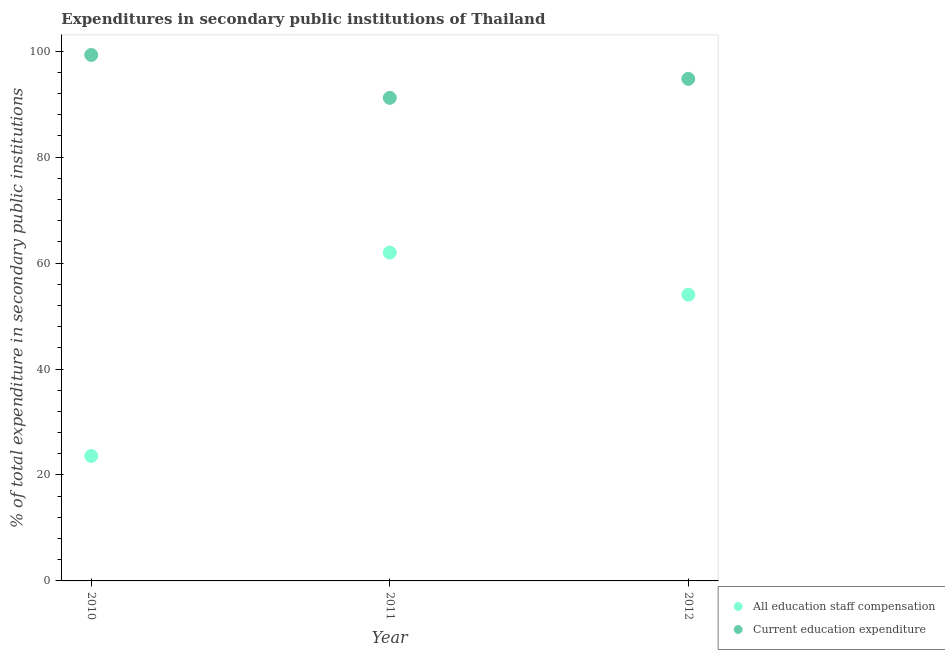What is the expenditure in staff compensation in 2010?
Offer a very short reply. 23.58. Across all years, what is the maximum expenditure in staff compensation?
Provide a short and direct response. 61.98. Across all years, what is the minimum expenditure in education?
Keep it short and to the point. 91.18. What is the total expenditure in education in the graph?
Keep it short and to the point. 285.24. What is the difference between the expenditure in staff compensation in 2010 and that in 2011?
Ensure brevity in your answer.  -38.4. What is the difference between the expenditure in staff compensation in 2011 and the expenditure in education in 2010?
Make the answer very short. -37.31. What is the average expenditure in staff compensation per year?
Make the answer very short. 46.53. In the year 2010, what is the difference between the expenditure in staff compensation and expenditure in education?
Offer a terse response. -75.7. What is the ratio of the expenditure in education in 2010 to that in 2011?
Your answer should be compact. 1.09. Is the expenditure in staff compensation in 2010 less than that in 2012?
Your answer should be compact. Yes. Is the difference between the expenditure in education in 2010 and 2012 greater than the difference between the expenditure in staff compensation in 2010 and 2012?
Offer a very short reply. Yes. What is the difference between the highest and the second highest expenditure in education?
Offer a very short reply. 4.52. What is the difference between the highest and the lowest expenditure in education?
Offer a very short reply. 8.1. Does the expenditure in staff compensation monotonically increase over the years?
Provide a succinct answer. No. Is the expenditure in education strictly less than the expenditure in staff compensation over the years?
Your answer should be compact. No. What is the difference between two consecutive major ticks on the Y-axis?
Your answer should be very brief. 20. Does the graph contain grids?
Offer a terse response. No. Where does the legend appear in the graph?
Give a very brief answer. Bottom right. What is the title of the graph?
Give a very brief answer. Expenditures in secondary public institutions of Thailand. What is the label or title of the Y-axis?
Keep it short and to the point. % of total expenditure in secondary public institutions. What is the % of total expenditure in secondary public institutions in All education staff compensation in 2010?
Provide a short and direct response. 23.58. What is the % of total expenditure in secondary public institutions of Current education expenditure in 2010?
Provide a succinct answer. 99.29. What is the % of total expenditure in secondary public institutions of All education staff compensation in 2011?
Make the answer very short. 61.98. What is the % of total expenditure in secondary public institutions in Current education expenditure in 2011?
Your answer should be very brief. 91.18. What is the % of total expenditure in secondary public institutions of All education staff compensation in 2012?
Your answer should be very brief. 54.03. What is the % of total expenditure in secondary public institutions in Current education expenditure in 2012?
Provide a succinct answer. 94.77. Across all years, what is the maximum % of total expenditure in secondary public institutions of All education staff compensation?
Make the answer very short. 61.98. Across all years, what is the maximum % of total expenditure in secondary public institutions in Current education expenditure?
Your answer should be compact. 99.29. Across all years, what is the minimum % of total expenditure in secondary public institutions of All education staff compensation?
Make the answer very short. 23.58. Across all years, what is the minimum % of total expenditure in secondary public institutions of Current education expenditure?
Make the answer very short. 91.18. What is the total % of total expenditure in secondary public institutions in All education staff compensation in the graph?
Offer a terse response. 139.59. What is the total % of total expenditure in secondary public institutions in Current education expenditure in the graph?
Make the answer very short. 285.24. What is the difference between the % of total expenditure in secondary public institutions in All education staff compensation in 2010 and that in 2011?
Your answer should be compact. -38.4. What is the difference between the % of total expenditure in secondary public institutions in Current education expenditure in 2010 and that in 2011?
Your answer should be compact. 8.1. What is the difference between the % of total expenditure in secondary public institutions in All education staff compensation in 2010 and that in 2012?
Offer a very short reply. -30.45. What is the difference between the % of total expenditure in secondary public institutions in Current education expenditure in 2010 and that in 2012?
Provide a succinct answer. 4.52. What is the difference between the % of total expenditure in secondary public institutions in All education staff compensation in 2011 and that in 2012?
Provide a short and direct response. 7.95. What is the difference between the % of total expenditure in secondary public institutions of Current education expenditure in 2011 and that in 2012?
Provide a short and direct response. -3.59. What is the difference between the % of total expenditure in secondary public institutions of All education staff compensation in 2010 and the % of total expenditure in secondary public institutions of Current education expenditure in 2011?
Your answer should be very brief. -67.6. What is the difference between the % of total expenditure in secondary public institutions in All education staff compensation in 2010 and the % of total expenditure in secondary public institutions in Current education expenditure in 2012?
Keep it short and to the point. -71.19. What is the difference between the % of total expenditure in secondary public institutions in All education staff compensation in 2011 and the % of total expenditure in secondary public institutions in Current education expenditure in 2012?
Ensure brevity in your answer.  -32.79. What is the average % of total expenditure in secondary public institutions in All education staff compensation per year?
Ensure brevity in your answer.  46.53. What is the average % of total expenditure in secondary public institutions in Current education expenditure per year?
Your answer should be compact. 95.08. In the year 2010, what is the difference between the % of total expenditure in secondary public institutions of All education staff compensation and % of total expenditure in secondary public institutions of Current education expenditure?
Your response must be concise. -75.7. In the year 2011, what is the difference between the % of total expenditure in secondary public institutions in All education staff compensation and % of total expenditure in secondary public institutions in Current education expenditure?
Offer a terse response. -29.2. In the year 2012, what is the difference between the % of total expenditure in secondary public institutions in All education staff compensation and % of total expenditure in secondary public institutions in Current education expenditure?
Provide a short and direct response. -40.74. What is the ratio of the % of total expenditure in secondary public institutions in All education staff compensation in 2010 to that in 2011?
Provide a succinct answer. 0.38. What is the ratio of the % of total expenditure in secondary public institutions of Current education expenditure in 2010 to that in 2011?
Make the answer very short. 1.09. What is the ratio of the % of total expenditure in secondary public institutions in All education staff compensation in 2010 to that in 2012?
Your answer should be very brief. 0.44. What is the ratio of the % of total expenditure in secondary public institutions of Current education expenditure in 2010 to that in 2012?
Give a very brief answer. 1.05. What is the ratio of the % of total expenditure in secondary public institutions of All education staff compensation in 2011 to that in 2012?
Your answer should be compact. 1.15. What is the ratio of the % of total expenditure in secondary public institutions in Current education expenditure in 2011 to that in 2012?
Provide a succinct answer. 0.96. What is the difference between the highest and the second highest % of total expenditure in secondary public institutions of All education staff compensation?
Keep it short and to the point. 7.95. What is the difference between the highest and the second highest % of total expenditure in secondary public institutions in Current education expenditure?
Ensure brevity in your answer.  4.52. What is the difference between the highest and the lowest % of total expenditure in secondary public institutions of All education staff compensation?
Offer a terse response. 38.4. What is the difference between the highest and the lowest % of total expenditure in secondary public institutions of Current education expenditure?
Offer a terse response. 8.1. 